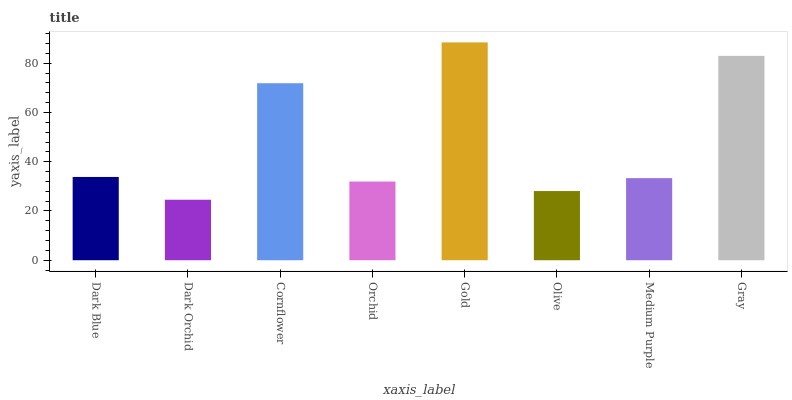Is Dark Orchid the minimum?
Answer yes or no. Yes. Is Gold the maximum?
Answer yes or no. Yes. Is Cornflower the minimum?
Answer yes or no. No. Is Cornflower the maximum?
Answer yes or no. No. Is Cornflower greater than Dark Orchid?
Answer yes or no. Yes. Is Dark Orchid less than Cornflower?
Answer yes or no. Yes. Is Dark Orchid greater than Cornflower?
Answer yes or no. No. Is Cornflower less than Dark Orchid?
Answer yes or no. No. Is Dark Blue the high median?
Answer yes or no. Yes. Is Medium Purple the low median?
Answer yes or no. Yes. Is Medium Purple the high median?
Answer yes or no. No. Is Dark Orchid the low median?
Answer yes or no. No. 